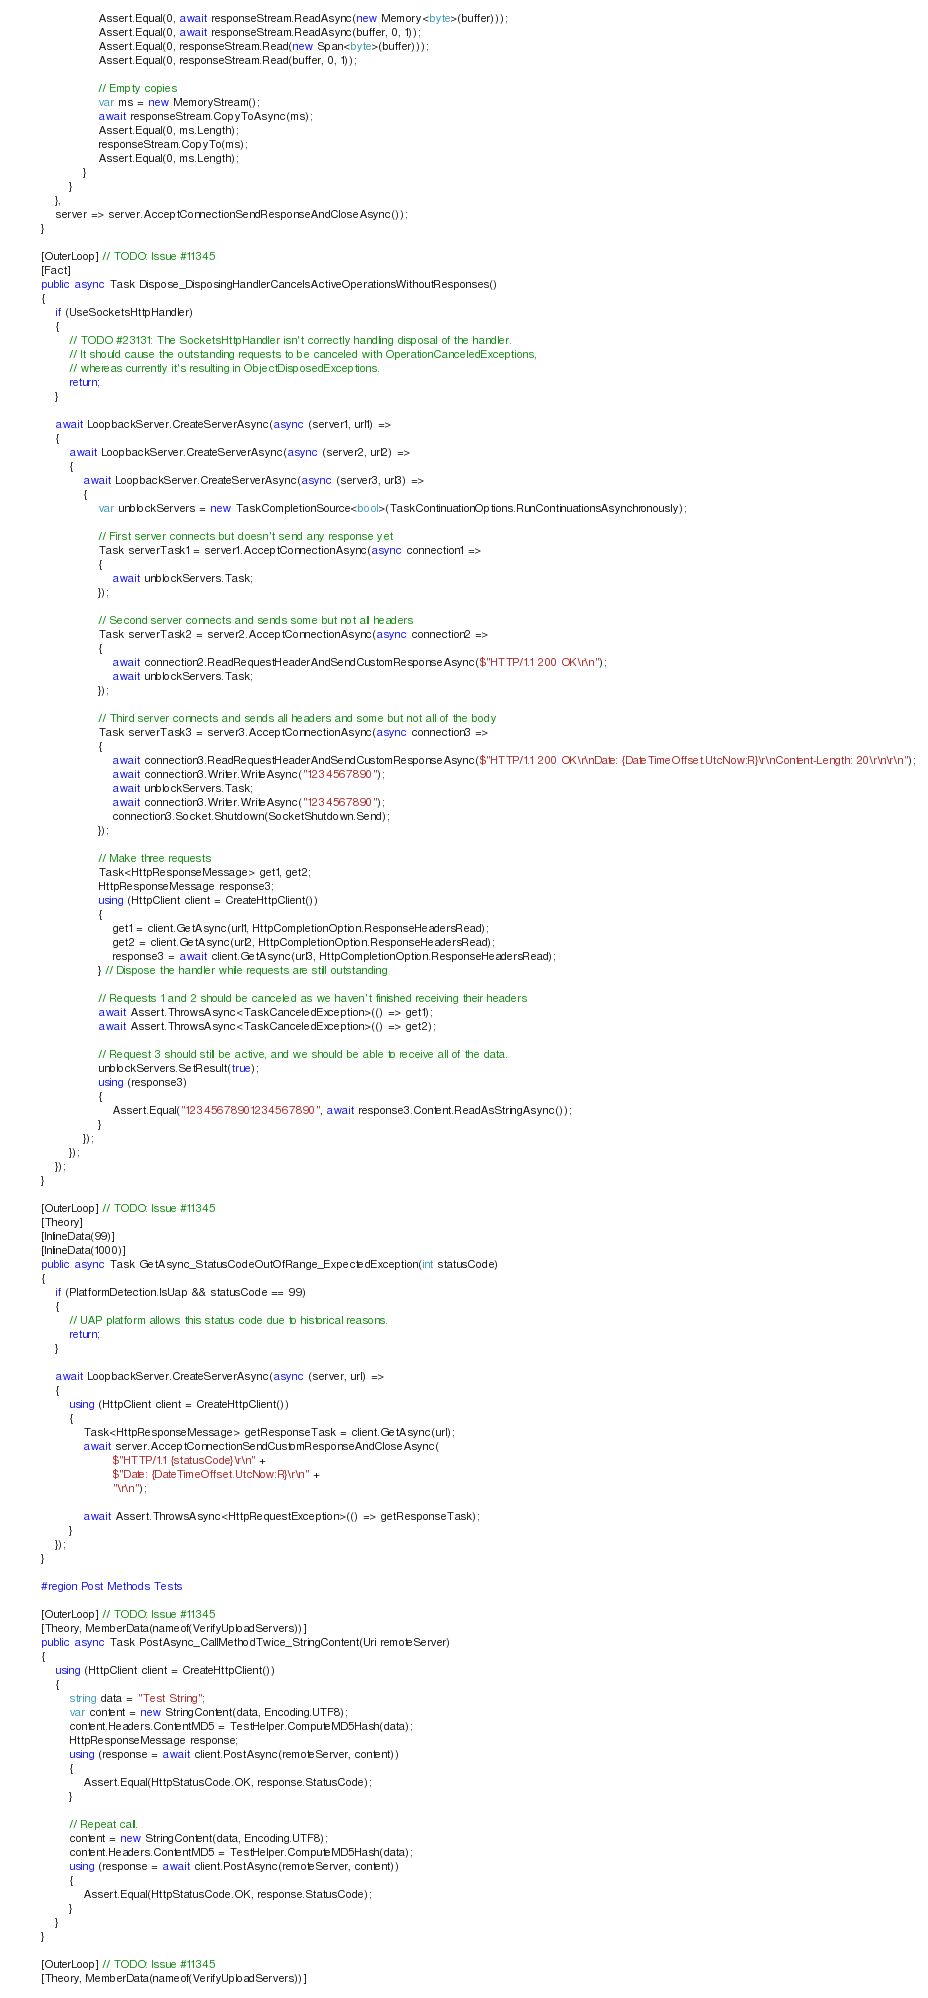<code> <loc_0><loc_0><loc_500><loc_500><_C#_>                        Assert.Equal(0, await responseStream.ReadAsync(new Memory<byte>(buffer)));
                        Assert.Equal(0, await responseStream.ReadAsync(buffer, 0, 1));
                        Assert.Equal(0, responseStream.Read(new Span<byte>(buffer)));
                        Assert.Equal(0, responseStream.Read(buffer, 0, 1));

                        // Empty copies
                        var ms = new MemoryStream();
                        await responseStream.CopyToAsync(ms);
                        Assert.Equal(0, ms.Length);
                        responseStream.CopyTo(ms);
                        Assert.Equal(0, ms.Length);
                    }
                }
            },
            server => server.AcceptConnectionSendResponseAndCloseAsync());
        }

        [OuterLoop] // TODO: Issue #11345
        [Fact]
        public async Task Dispose_DisposingHandlerCancelsActiveOperationsWithoutResponses()
        {
            if (UseSocketsHttpHandler)
            {
                // TODO #23131: The SocketsHttpHandler isn't correctly handling disposal of the handler.
                // It should cause the outstanding requests to be canceled with OperationCanceledExceptions,
                // whereas currently it's resulting in ObjectDisposedExceptions.
                return;
            }

            await LoopbackServer.CreateServerAsync(async (server1, url1) =>
            {
                await LoopbackServer.CreateServerAsync(async (server2, url2) =>
                {
                    await LoopbackServer.CreateServerAsync(async (server3, url3) =>
                    {
                        var unblockServers = new TaskCompletionSource<bool>(TaskContinuationOptions.RunContinuationsAsynchronously);

                        // First server connects but doesn't send any response yet
                        Task serverTask1 = server1.AcceptConnectionAsync(async connection1 =>
                        {
                            await unblockServers.Task;
                        });

                        // Second server connects and sends some but not all headers
                        Task serverTask2 = server2.AcceptConnectionAsync(async connection2 =>
                        {
                            await connection2.ReadRequestHeaderAndSendCustomResponseAsync($"HTTP/1.1 200 OK\r\n");
                            await unblockServers.Task;
                        });

                        // Third server connects and sends all headers and some but not all of the body
                        Task serverTask3 = server3.AcceptConnectionAsync(async connection3 =>
                        {
                            await connection3.ReadRequestHeaderAndSendCustomResponseAsync($"HTTP/1.1 200 OK\r\nDate: {DateTimeOffset.UtcNow:R}\r\nContent-Length: 20\r\n\r\n");
                            await connection3.Writer.WriteAsync("1234567890");
                            await unblockServers.Task;
                            await connection3.Writer.WriteAsync("1234567890");
                            connection3.Socket.Shutdown(SocketShutdown.Send);
                        });

                        // Make three requests
                        Task<HttpResponseMessage> get1, get2;
                        HttpResponseMessage response3;
                        using (HttpClient client = CreateHttpClient())
                        {
                            get1 = client.GetAsync(url1, HttpCompletionOption.ResponseHeadersRead);
                            get2 = client.GetAsync(url2, HttpCompletionOption.ResponseHeadersRead);
                            response3 = await client.GetAsync(url3, HttpCompletionOption.ResponseHeadersRead);
                        } // Dispose the handler while requests are still outstanding

                        // Requests 1 and 2 should be canceled as we haven't finished receiving their headers
                        await Assert.ThrowsAsync<TaskCanceledException>(() => get1);
                        await Assert.ThrowsAsync<TaskCanceledException>(() => get2);

                        // Request 3 should still be active, and we should be able to receive all of the data.
                        unblockServers.SetResult(true);
                        using (response3)
                        {
                            Assert.Equal("12345678901234567890", await response3.Content.ReadAsStringAsync());
                        }
                    });
                });
            });
        }

        [OuterLoop] // TODO: Issue #11345
        [Theory]
        [InlineData(99)]
        [InlineData(1000)]
        public async Task GetAsync_StatusCodeOutOfRange_ExpectedException(int statusCode)
        {
            if (PlatformDetection.IsUap && statusCode == 99)
            {
                // UAP platform allows this status code due to historical reasons.
                return;
            }

            await LoopbackServer.CreateServerAsync(async (server, url) =>
            {
                using (HttpClient client = CreateHttpClient())
                {
                    Task<HttpResponseMessage> getResponseTask = client.GetAsync(url);
                    await server.AcceptConnectionSendCustomResponseAndCloseAsync(
                            $"HTTP/1.1 {statusCode}\r\n" +
                            $"Date: {DateTimeOffset.UtcNow:R}\r\n" +
                            "\r\n");

                    await Assert.ThrowsAsync<HttpRequestException>(() => getResponseTask);
                }
            });
        }

        #region Post Methods Tests

        [OuterLoop] // TODO: Issue #11345
        [Theory, MemberData(nameof(VerifyUploadServers))]
        public async Task PostAsync_CallMethodTwice_StringContent(Uri remoteServer)
        {
            using (HttpClient client = CreateHttpClient())
            {
                string data = "Test String";
                var content = new StringContent(data, Encoding.UTF8);
                content.Headers.ContentMD5 = TestHelper.ComputeMD5Hash(data);
                HttpResponseMessage response;
                using (response = await client.PostAsync(remoteServer, content))
                {
                    Assert.Equal(HttpStatusCode.OK, response.StatusCode);
                }

                // Repeat call.
                content = new StringContent(data, Encoding.UTF8);
                content.Headers.ContentMD5 = TestHelper.ComputeMD5Hash(data);
                using (response = await client.PostAsync(remoteServer, content))
                {
                    Assert.Equal(HttpStatusCode.OK, response.StatusCode);
                }
            }
        }

        [OuterLoop] // TODO: Issue #11345
        [Theory, MemberData(nameof(VerifyUploadServers))]</code> 